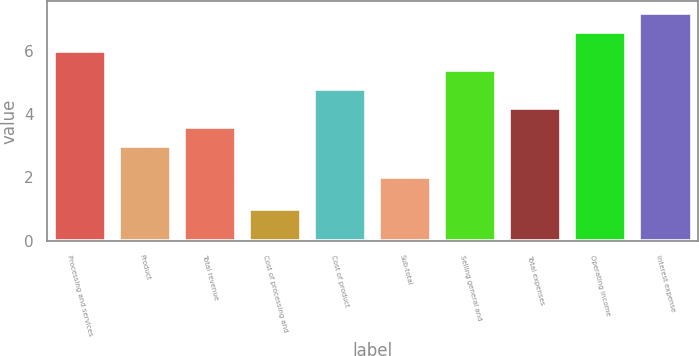<chart> <loc_0><loc_0><loc_500><loc_500><bar_chart><fcel>Processing and services<fcel>Product<fcel>Total revenue<fcel>Cost of processing and<fcel>Cost of product<fcel>Sub-total<fcel>Selling general and<fcel>Total expenses<fcel>Operating income<fcel>Interest expense<nl><fcel>6<fcel>3<fcel>3.6<fcel>1<fcel>4.8<fcel>2<fcel>5.4<fcel>4.2<fcel>6.6<fcel>7.2<nl></chart> 